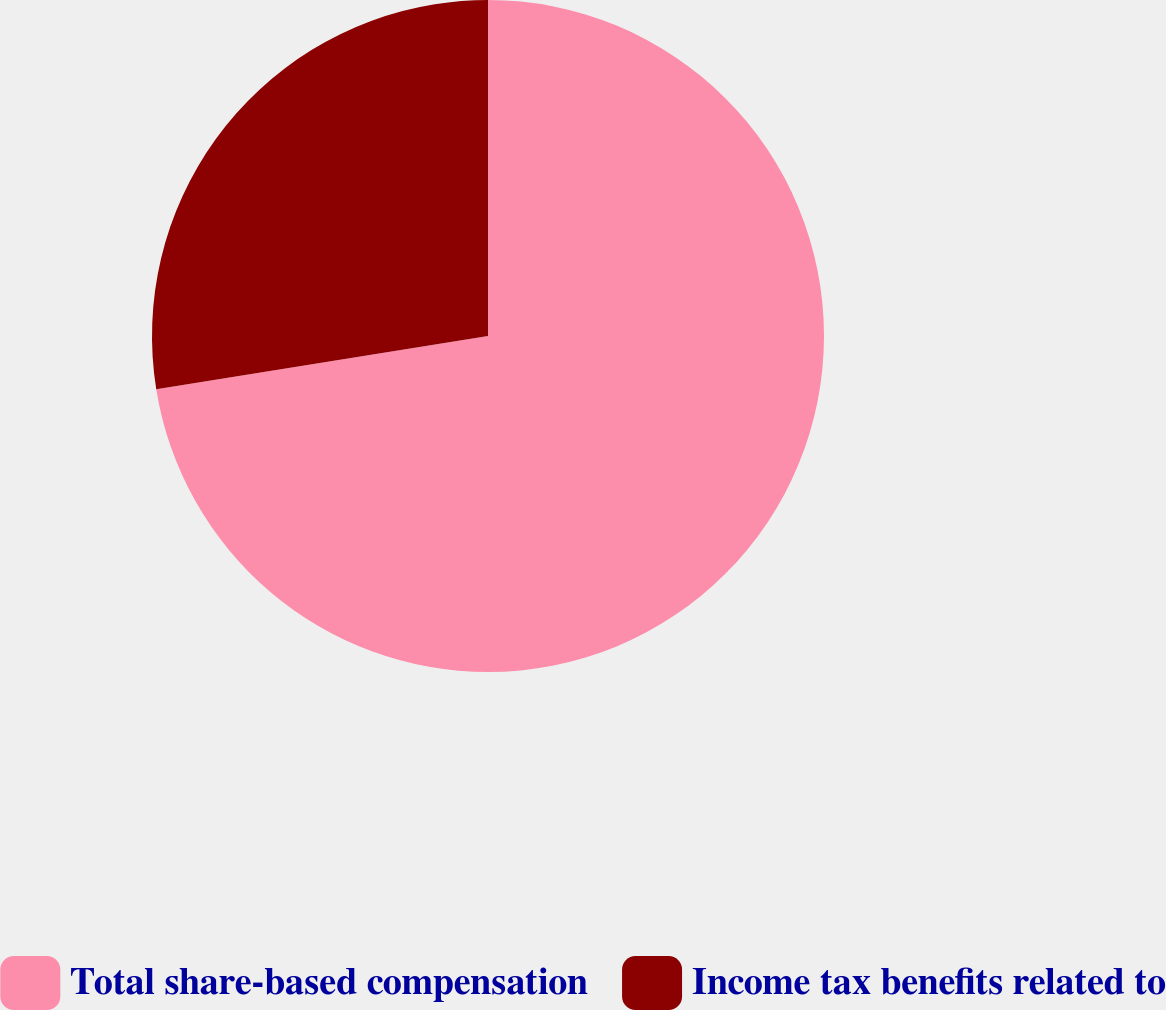<chart> <loc_0><loc_0><loc_500><loc_500><pie_chart><fcel>Total share-based compensation<fcel>Income tax benefits related to<nl><fcel>72.47%<fcel>27.53%<nl></chart> 